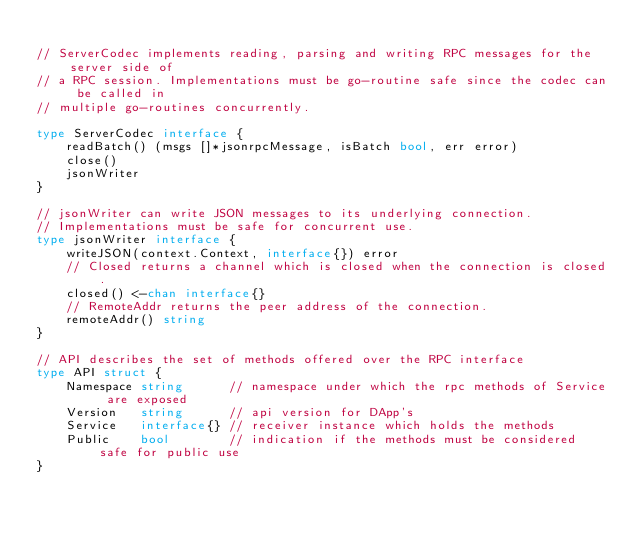Convert code to text. <code><loc_0><loc_0><loc_500><loc_500><_Go_>
// ServerCodec implements reading, parsing and writing RPC messages for the server side of
// a RPC session. Implementations must be go-routine safe since the codec can be called in
// multiple go-routines concurrently.

type ServerCodec interface {
	readBatch() (msgs []*jsonrpcMessage, isBatch bool, err error)
	close()
	jsonWriter
}

// jsonWriter can write JSON messages to its underlying connection.
// Implementations must be safe for concurrent use.
type jsonWriter interface {
	writeJSON(context.Context, interface{}) error
	// Closed returns a channel which is closed when the connection is closed.
	closed() <-chan interface{}
	// RemoteAddr returns the peer address of the connection.
	remoteAddr() string
}

// API describes the set of methods offered over the RPC interface
type API struct {
	Namespace string      // namespace under which the rpc methods of Service are exposed
	Version   string      // api version for DApp's
	Service   interface{} // receiver instance which holds the methods
	Public    bool        // indication if the methods must be considered safe for public use
}
</code> 